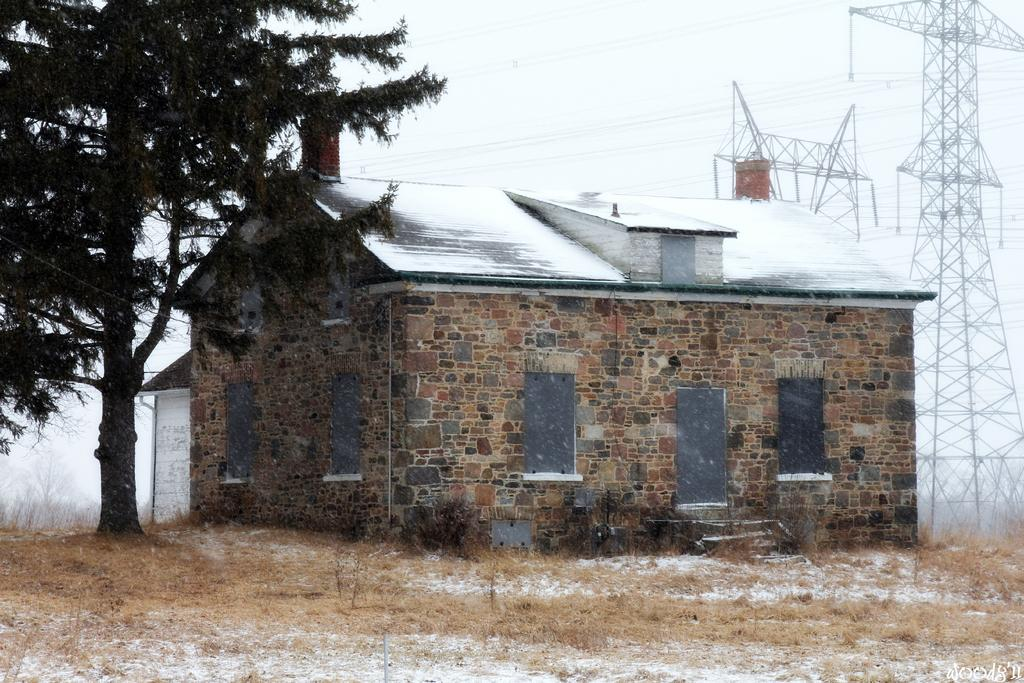What type of vegetation is on the ground in the image? There is dried grass on the ground in the image. What structures can be seen in the background of the image? There are sheds and poles in the background of the image. What natural element is visible in the background of the image? There is a tree in the background of the image. What is visible above the structures and vegetation in the image? The sky is visible in the background of the image. Can you see any fairies flying around the tree in the image? There are no fairies present in the image; it only shows dried grass, sheds, poles, a tree, and the sky. What type of oil can be seen dripping from the poles in the image? There is no oil present in the image; it only shows dried grass, sheds, poles, a tree, and the sky. 